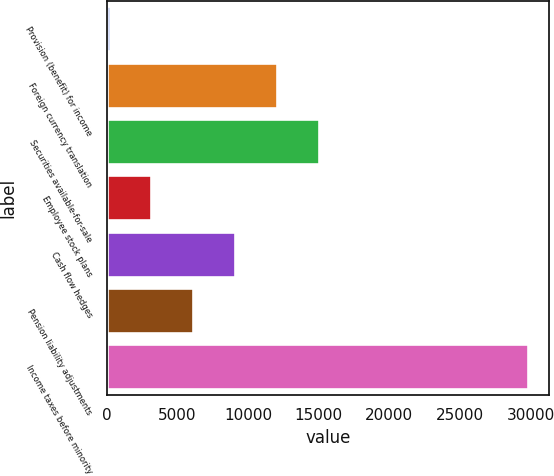<chart> <loc_0><loc_0><loc_500><loc_500><bar_chart><fcel>Provision (benefit) for income<fcel>Foreign currency translation<fcel>Securities available-for-sale<fcel>Employee stock plans<fcel>Cash flow hedges<fcel>Pension liability adjustments<fcel>Income taxes before minority<nl><fcel>207<fcel>12049<fcel>15009.5<fcel>3167.5<fcel>9088.5<fcel>6128<fcel>29812<nl></chart> 